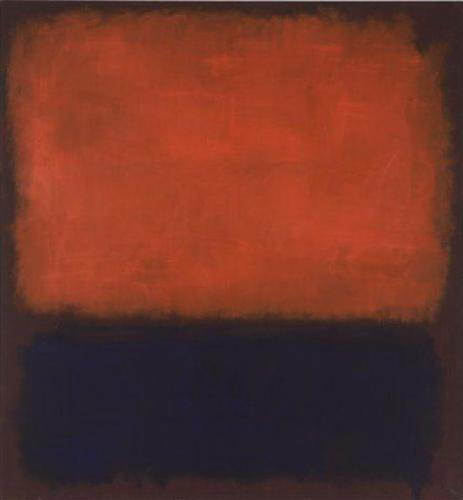What emotions do you think this artwork evokes? The artwork likely evokes a range of emotions, primarily driven by its bold use of colors and textures. The intense red hue may evoke feelings of passion, intensity, or even anger, while the contrasting black section can convey a sense of mystery, depth, or solemnity. The textured red above the smooth black creates a sense of tension and contrast, potentially suggesting an inner turmoil or conflict. Overall, the piece exudes a somber mood, perhaps reflecting on profound themes such as existentialism or the human condition. 